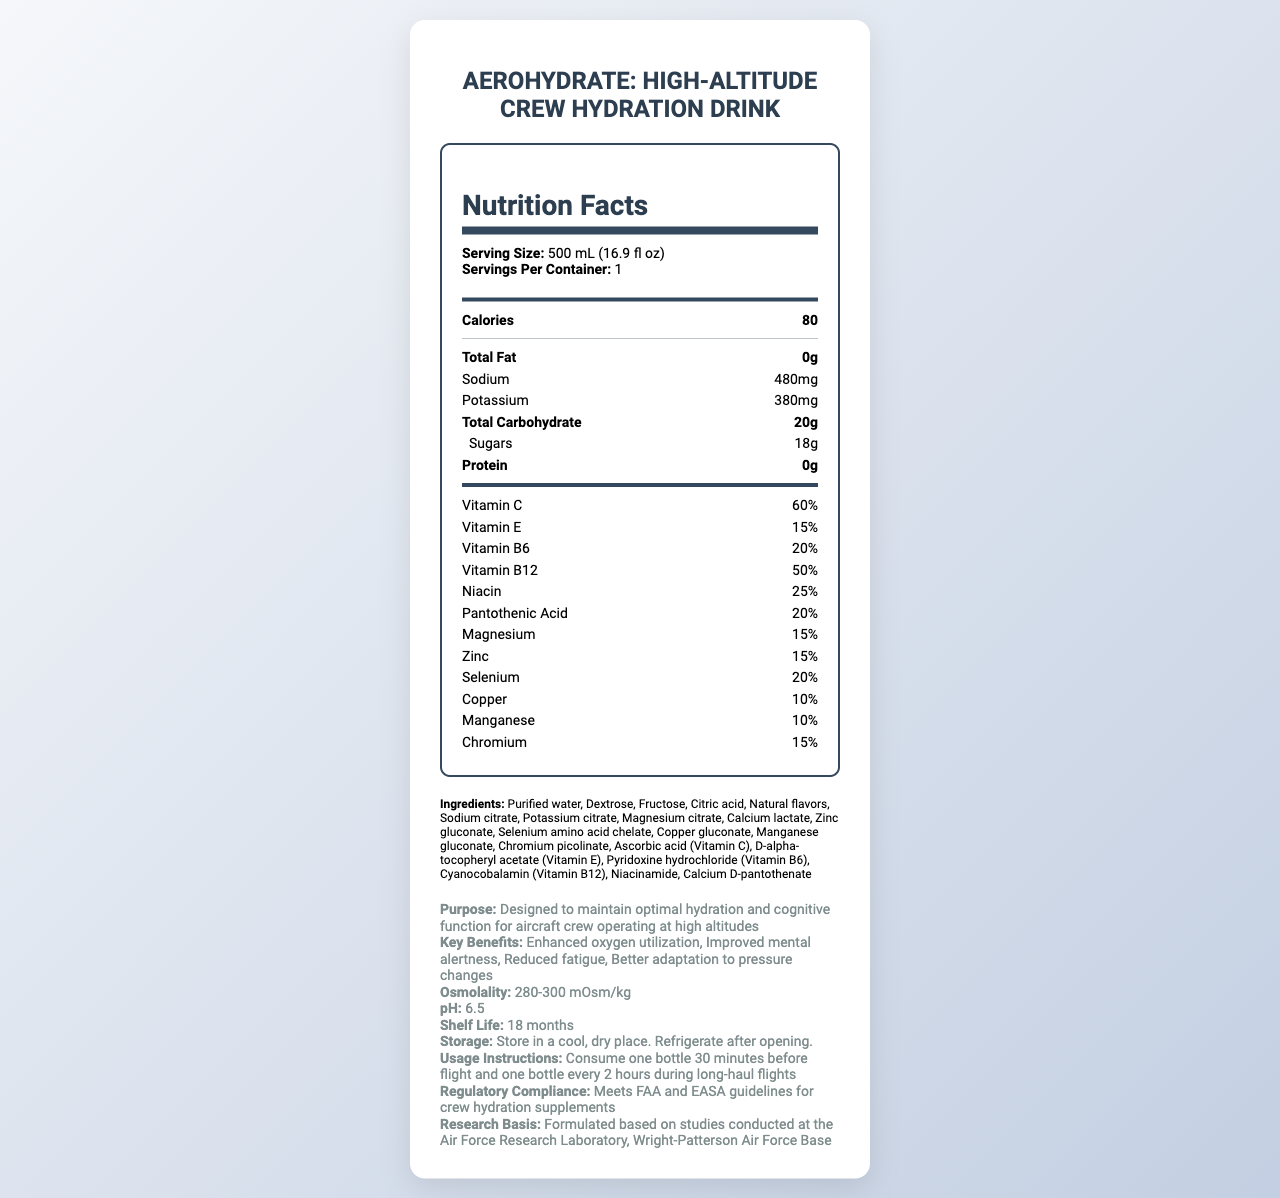what is the serving size of the hydration drink? The serving size is listed under "Serving Size" in the document.
Answer: 500 mL (16.9 fl oz) how many calories does one serving contain? The number of calories is shown as "Calories" in the nutrition facts.
Answer: 80 what is the amount of sodium in one serving? The amount of sodium is indicated next to "Sodium" in the nutrition facts section.
Answer: 480 mg name three minerals included in the hydration drink. The minerals are found in the list under the "nutrition facts" segment.
Answer: Magnesium, Zinc, Selenium how much potassium is in each serving? The potassium content is shown next to "Potassium" in the nutrition facts section.
Answer: 380 mg which vitamin has the highest percentage in the drink? A. Vitamin C B. Vitamin E C. Vitamin B12 D. Niacin Vitamin B12 has a percentage value of 50%, which is higher than the values for the other vitamins listed.
Answer: C. Vitamin B12 what is the main benefit of this hydration drink according to the document? A. Enhanced oxygen utilization B. Improved digestion C. Lower blood pressure D. Increased muscle mass One of the key benefits listed under "Key Benefits" is "Enhanced oxygen utilization."
Answer: A. Enhanced oxygen utilization is this hydration drink compliant with FAA and EASA guidelines? The document states that the product meets FAA and EASA guidelines for crew hydration supplements under "Regulatory Compliance."
Answer: Yes how many sugars are there in one serving? The amount of sugars is listed under "Sugars" in the nutrition facts section.
Answer: 18 g describe the intended purpose of AeroHydrate: High-Altitude Crew Hydration Drink. The purpose is stated in the additional info section under "Purpose."
Answer: The drink is designed to maintain optimal hydration and cognitive function for aircraft crew operating at high altitudes. what studies was this product formulation based on? The specific studies are not detailed in the document, only mentioning general studies conducted at the Air Force Research Laboratory.
Answer: I don't know how should the product be stored after opening? The storage instructions state to store in a cool, dry place and to refrigerate after opening.
Answer: Refrigerate after opening when should the hydration drink be consumed according to the usage instructions? The usage instructions provide specific timing for consumption before and during flights.
Answer: Consume one bottle 30 minutes before flight and one bottle every 2 hours during long-haul flights. what is the osmolality range of the hydration drink? Osmolality information is listed under "Osmolality" in the additional info section.
Answer: 280-300 mOsm/kg how long is the shelf life of AeroHydrate? The shelf life is listed as 18 months in the additional info section.
Answer: 18 months what is the pH level of the hydration drink? The pH level is provided as 6.5 in the additional info section.
Answer: 6.5 identify one of the sweeteners used in this hydration drink. Dextrose is listed as one of the ingredients.
Answer: Dextrose 